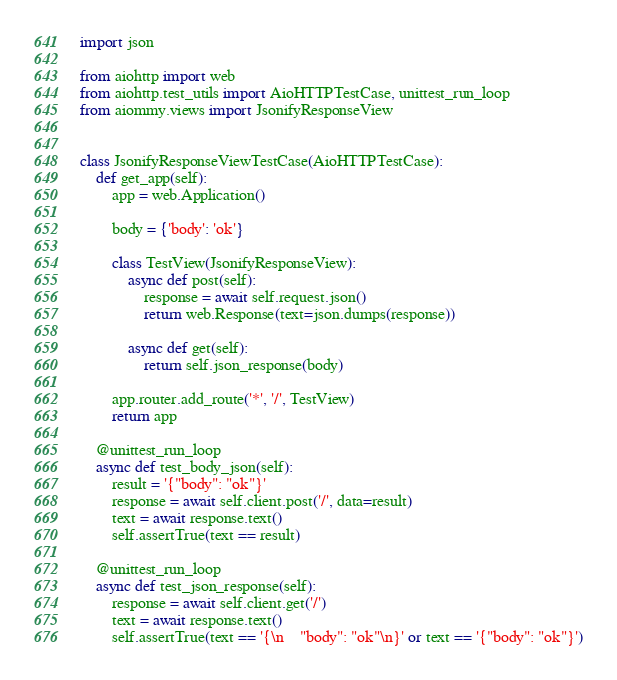<code> <loc_0><loc_0><loc_500><loc_500><_Python_>import json

from aiohttp import web
from aiohttp.test_utils import AioHTTPTestCase, unittest_run_loop
from aiommy.views import JsonifyResponseView


class JsonifyResponseViewTestCase(AioHTTPTestCase):
    def get_app(self):
        app = web.Application()

        body = {'body': 'ok'}

        class TestView(JsonifyResponseView):
            async def post(self):
                response = await self.request.json()
                return web.Response(text=json.dumps(response))

            async def get(self):
                return self.json_response(body)

        app.router.add_route('*', '/', TestView)
        return app

    @unittest_run_loop
    async def test_body_json(self):
        result = '{"body": "ok"}'
        response = await self.client.post('/', data=result)
        text = await response.text()
        self.assertTrue(text == result)

    @unittest_run_loop
    async def test_json_response(self):
        response = await self.client.get('/')
        text = await response.text()
        self.assertTrue(text == '{\n    "body": "ok"\n}' or text == '{"body": "ok"}')
</code> 